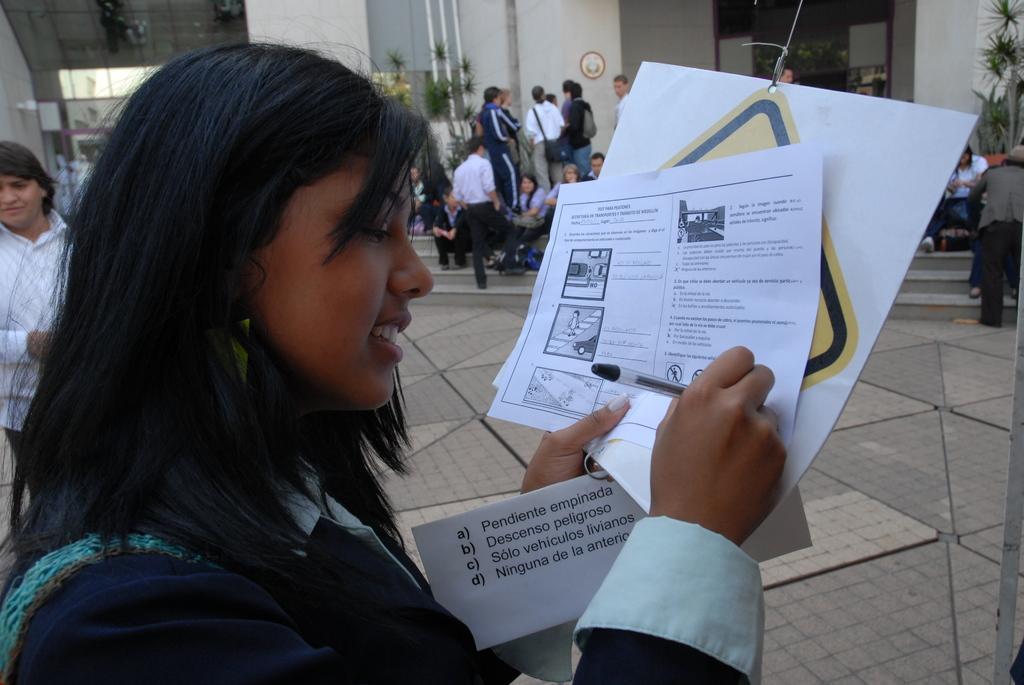Please provide a concise description of this image. In the foreground of the picture there is a woman holding papers. On the left there is a person. On the right there are people sitting on staircase and there are plants. In the center of the background there are people, plants, wall, pipe and door. In the background towards left there is a building. 